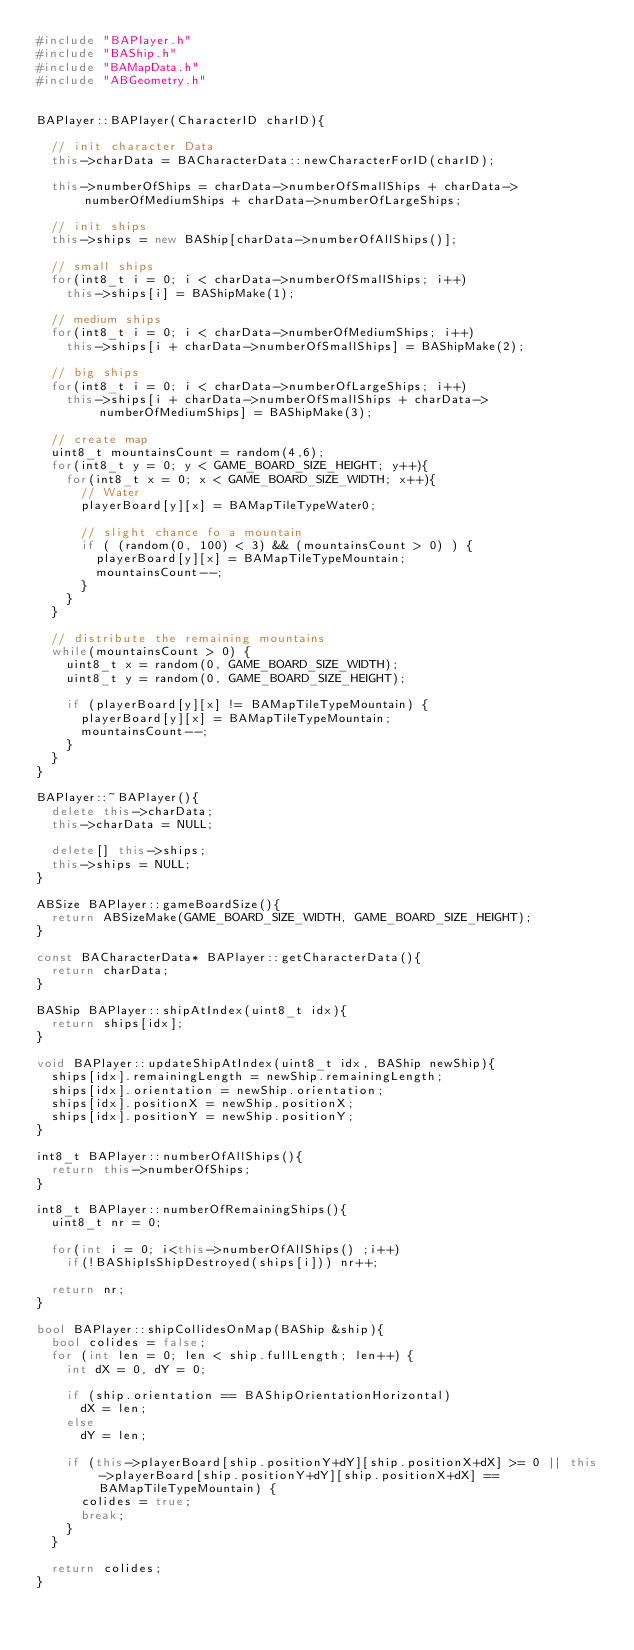Convert code to text. <code><loc_0><loc_0><loc_500><loc_500><_C++_>#include "BAPlayer.h"
#include "BAShip.h"
#include "BAMapData.h"
#include "ABGeometry.h"


BAPlayer::BAPlayer(CharacterID charID){

  // init character Data
  this->charData = BACharacterData::newCharacterForID(charID);

  this->numberOfShips = charData->numberOfSmallShips + charData->numberOfMediumShips + charData->numberOfLargeShips;

  // init ships
  this->ships = new BAShip[charData->numberOfAllShips()];

  // small ships
  for(int8_t i = 0; i < charData->numberOfSmallShips; i++)
    this->ships[i] = BAShipMake(1);

  // medium ships
  for(int8_t i = 0; i < charData->numberOfMediumShips; i++)
    this->ships[i + charData->numberOfSmallShips] = BAShipMake(2);

  // big ships
  for(int8_t i = 0; i < charData->numberOfLargeShips; i++)
    this->ships[i + charData->numberOfSmallShips + charData->numberOfMediumShips] = BAShipMake(3);

  // create map
  uint8_t mountainsCount = random(4,6);
  for(int8_t y = 0; y < GAME_BOARD_SIZE_HEIGHT; y++){
    for(int8_t x = 0; x < GAME_BOARD_SIZE_WIDTH; x++){
      // Water
      playerBoard[y][x] = BAMapTileTypeWater0;

      // slight chance fo a mountain
      if ( (random(0, 100) < 3) && (mountainsCount > 0) ) {
        playerBoard[y][x] = BAMapTileTypeMountain;
        mountainsCount--;
      }
    }
  }

  // distribute the remaining mountains
  while(mountainsCount > 0) {
    uint8_t x = random(0, GAME_BOARD_SIZE_WIDTH);
    uint8_t y = random(0, GAME_BOARD_SIZE_HEIGHT);

    if (playerBoard[y][x] != BAMapTileTypeMountain) {
      playerBoard[y][x] = BAMapTileTypeMountain;
      mountainsCount--;
    }
  }
}

BAPlayer::~BAPlayer(){
  delete this->charData;
  this->charData = NULL;

  delete[] this->ships;
  this->ships = NULL;
}

ABSize BAPlayer::gameBoardSize(){
  return ABSizeMake(GAME_BOARD_SIZE_WIDTH, GAME_BOARD_SIZE_HEIGHT);
}

const BACharacterData* BAPlayer::getCharacterData(){
  return charData;
}

BAShip BAPlayer::shipAtIndex(uint8_t idx){
  return ships[idx];
}

void BAPlayer::updateShipAtIndex(uint8_t idx, BAShip newShip){
  ships[idx].remainingLength = newShip.remainingLength;
  ships[idx].orientation = newShip.orientation;
  ships[idx].positionX = newShip.positionX;
  ships[idx].positionY = newShip.positionY;
}

int8_t BAPlayer::numberOfAllShips(){
  return this->numberOfShips;
}

int8_t BAPlayer::numberOfRemainingShips(){
  uint8_t nr = 0;

  for(int i = 0; i<this->numberOfAllShips() ;i++)
    if(!BAShipIsShipDestroyed(ships[i])) nr++;

  return nr;
}

bool BAPlayer::shipCollidesOnMap(BAShip &ship){
  bool colides = false;
  for (int len = 0; len < ship.fullLength; len++) {
    int dX = 0, dY = 0;

    if (ship.orientation == BAShipOrientationHorizontal)
      dX = len;
    else
      dY = len;

    if (this->playerBoard[ship.positionY+dY][ship.positionX+dX] >= 0 || this->playerBoard[ship.positionY+dY][ship.positionX+dX] == BAMapTileTypeMountain) {
      colides = true;
      break;
    }
  }

  return colides;
}
</code> 